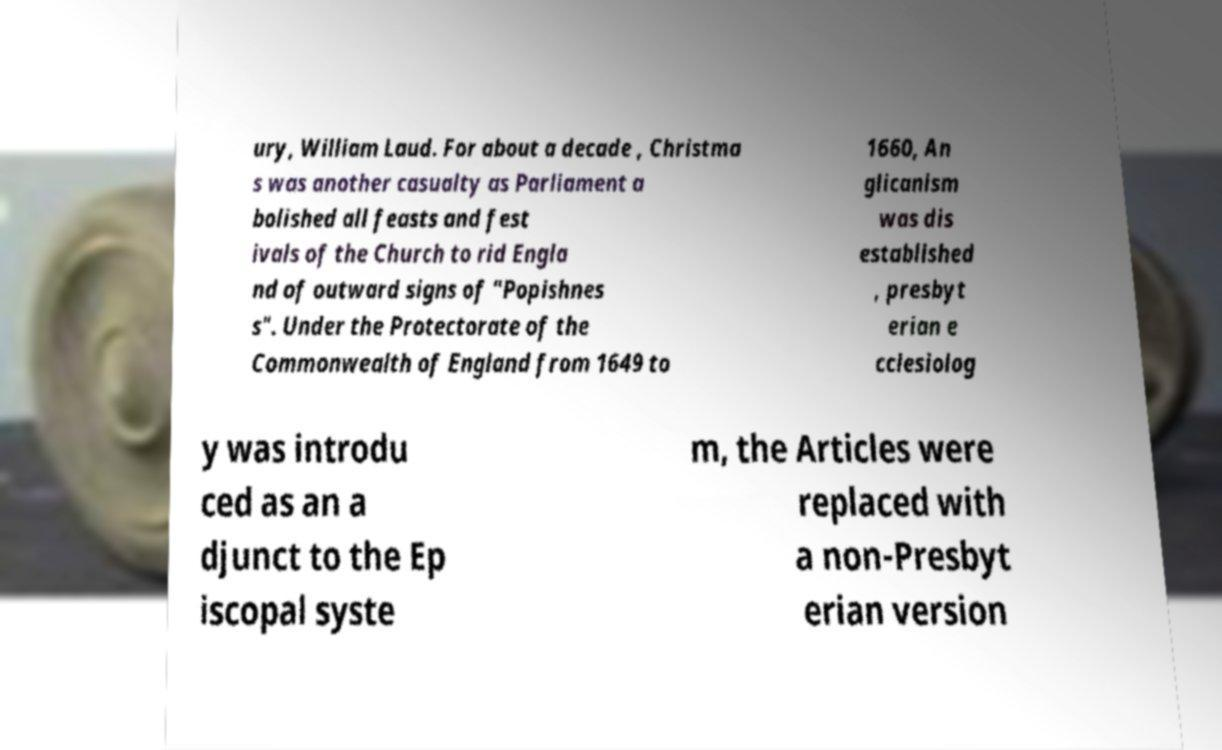What messages or text are displayed in this image? I need them in a readable, typed format. ury, William Laud. For about a decade , Christma s was another casualty as Parliament a bolished all feasts and fest ivals of the Church to rid Engla nd of outward signs of "Popishnes s". Under the Protectorate of the Commonwealth of England from 1649 to 1660, An glicanism was dis established , presbyt erian e cclesiolog y was introdu ced as an a djunct to the Ep iscopal syste m, the Articles were replaced with a non-Presbyt erian version 